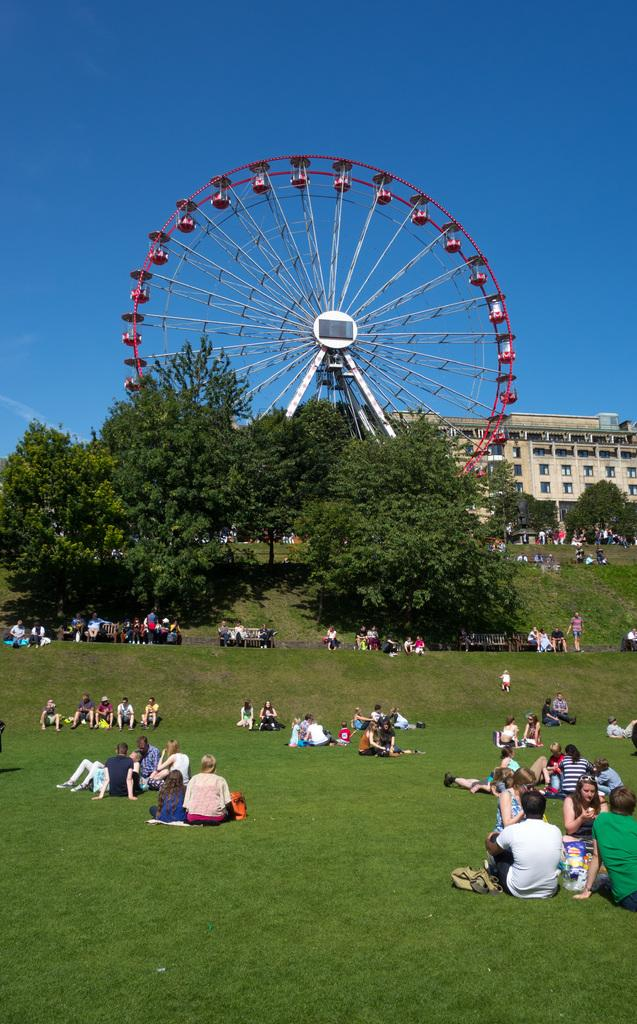What are the people in the image doing? The people in the image are sitting on the grass and benches. What can be seen behind the people? There are trees and a giant wheel in the background. What other structure is visible in the background? There is a building in the background. What type of eggnog is being served at the event in the image? There is no mention of eggnog or any event in the image; it simply shows people sitting on the grass and benches with trees, a giant wheel, and a building in the background. 